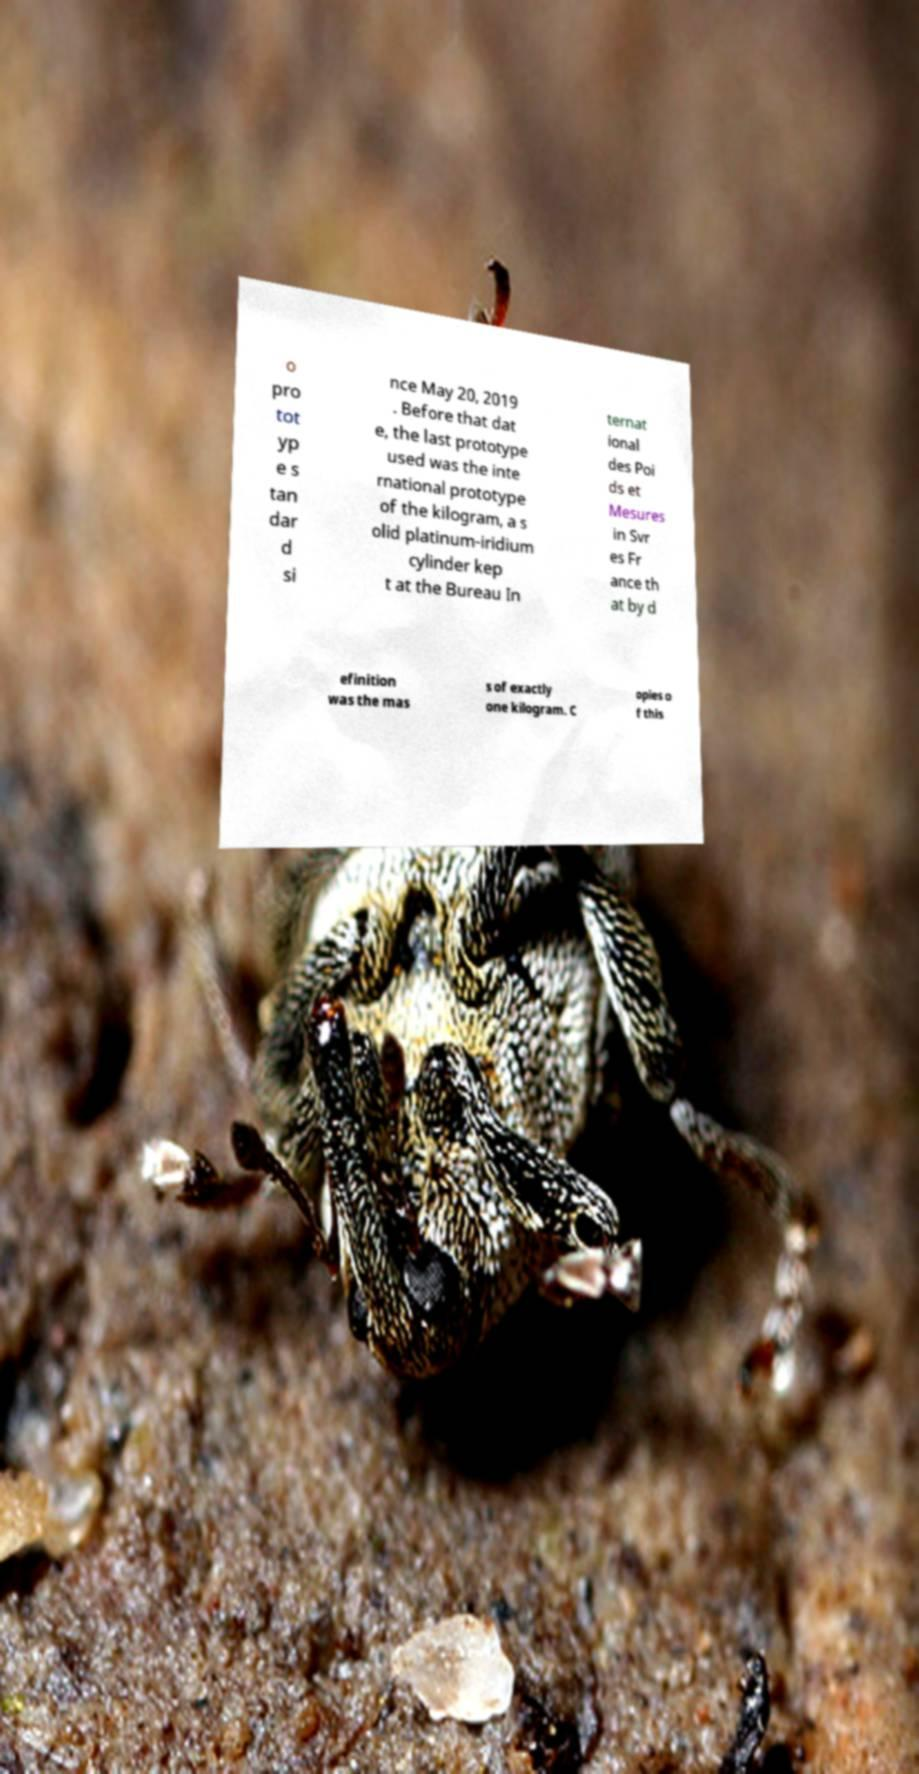Can you read and provide the text displayed in the image?This photo seems to have some interesting text. Can you extract and type it out for me? o pro tot yp e s tan dar d si nce May 20, 2019 . Before that dat e, the last prototype used was the inte rnational prototype of the kilogram, a s olid platinum-iridium cylinder kep t at the Bureau In ternat ional des Poi ds et Mesures in Svr es Fr ance th at by d efinition was the mas s of exactly one kilogram. C opies o f this 